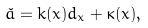<formula> <loc_0><loc_0><loc_500><loc_500>\check { a } = k ( x ) d _ { x } + \kappa ( x ) ,</formula> 